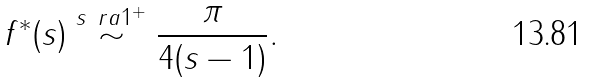Convert formula to latex. <formula><loc_0><loc_0><loc_500><loc_500>f ^ { * } ( s ) \stackrel { s \ r a 1 ^ { + } } { \sim } \frac { \pi } { 4 ( s - 1 ) } .</formula> 